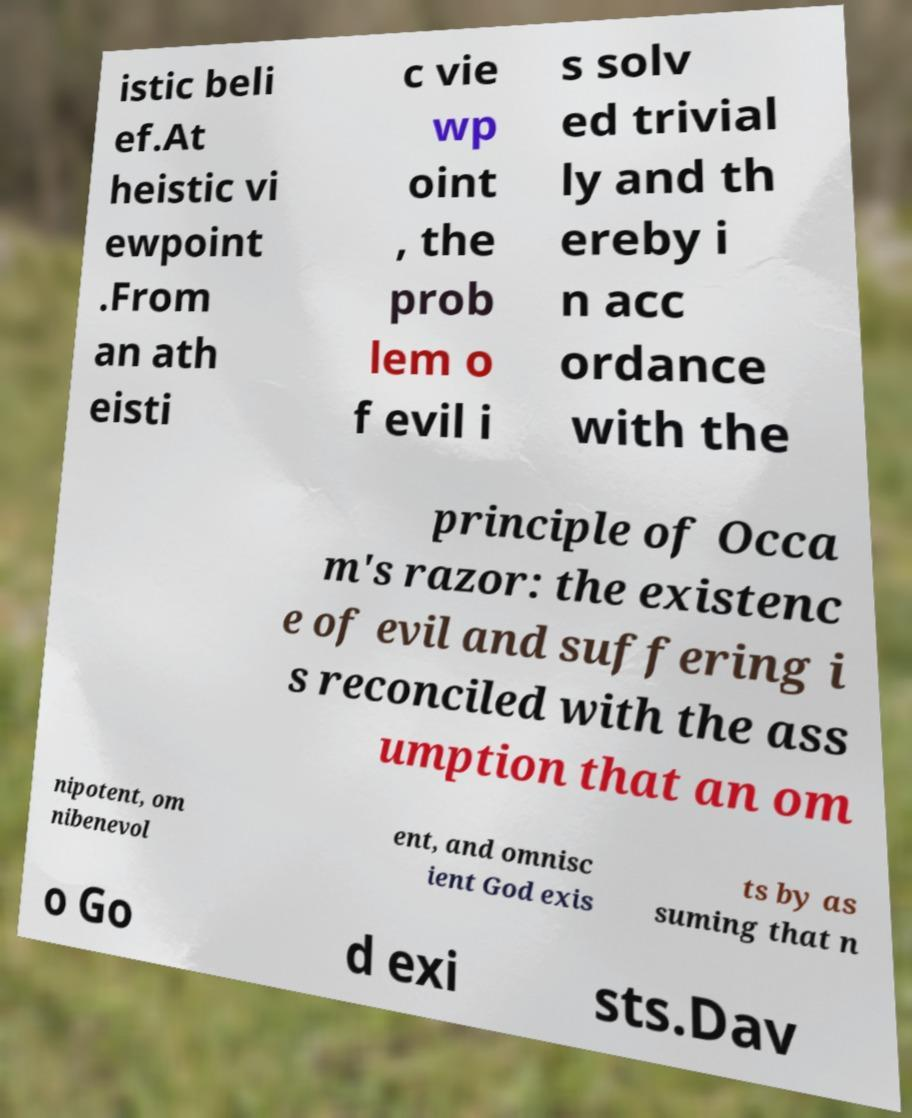Can you accurately transcribe the text from the provided image for me? istic beli ef.At heistic vi ewpoint .From an ath eisti c vie wp oint , the prob lem o f evil i s solv ed trivial ly and th ereby i n acc ordance with the principle of Occa m's razor: the existenc e of evil and suffering i s reconciled with the ass umption that an om nipotent, om nibenevol ent, and omnisc ient God exis ts by as suming that n o Go d exi sts.Dav 